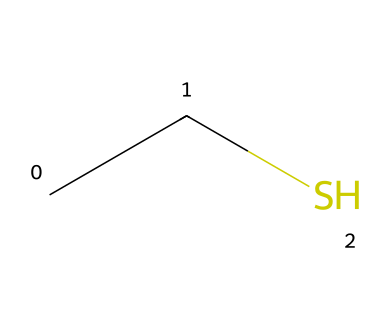What is the name of this compound? The SMILES representation 'CCS' corresponds to Ethanethiol, which is commonly known as ethyl mercaptan. This is derived from the fact that the presence of two carbon atoms (CC) and a sulfur atom (S) forms this specific thiol compound.
Answer: Ethanethiol How many carbon atoms are present in the compound? The SMILES representation 'CCS' contains two carbon atoms indicated by the 'CC', where each 'C' represents one carbon atom linked together.
Answer: 2 What type of functional group is present in this compound? The presence of the sulfur atom (S) attached to an alkyl chain (derived from the two carbon atoms) indicates that the functional group of this compound is a thiol, which is characterized by the R-SH structure.
Answer: Thiol What is the total number of atoms in the molecule? In the SMILES representation 'CCS', there are a total of five atoms: two carbon atoms (C), six hydrogen atoms (H, inferred by the tetravalency of carbon), and one sulfur atom (S). Summing these gives a total of 5 atoms.
Answer: 5 Does this thiol compound have a strong odor? Thiols are known for their strong and often unpleasant odors, commonly associated with rotten eggs or garlic, due to the presence of the sulfur atom, which contributes to volatiles that emit noticeable scents.
Answer: Yes What type of bonds are present in this compound? The SMILES representation 'CCS' shows single covalent bonds between the carbon atoms and between the carbon and sulfur atom, which is typical for aliphatic thiols. Thus, the primary bond type expressed in this compound is single bonds.
Answer: Single 